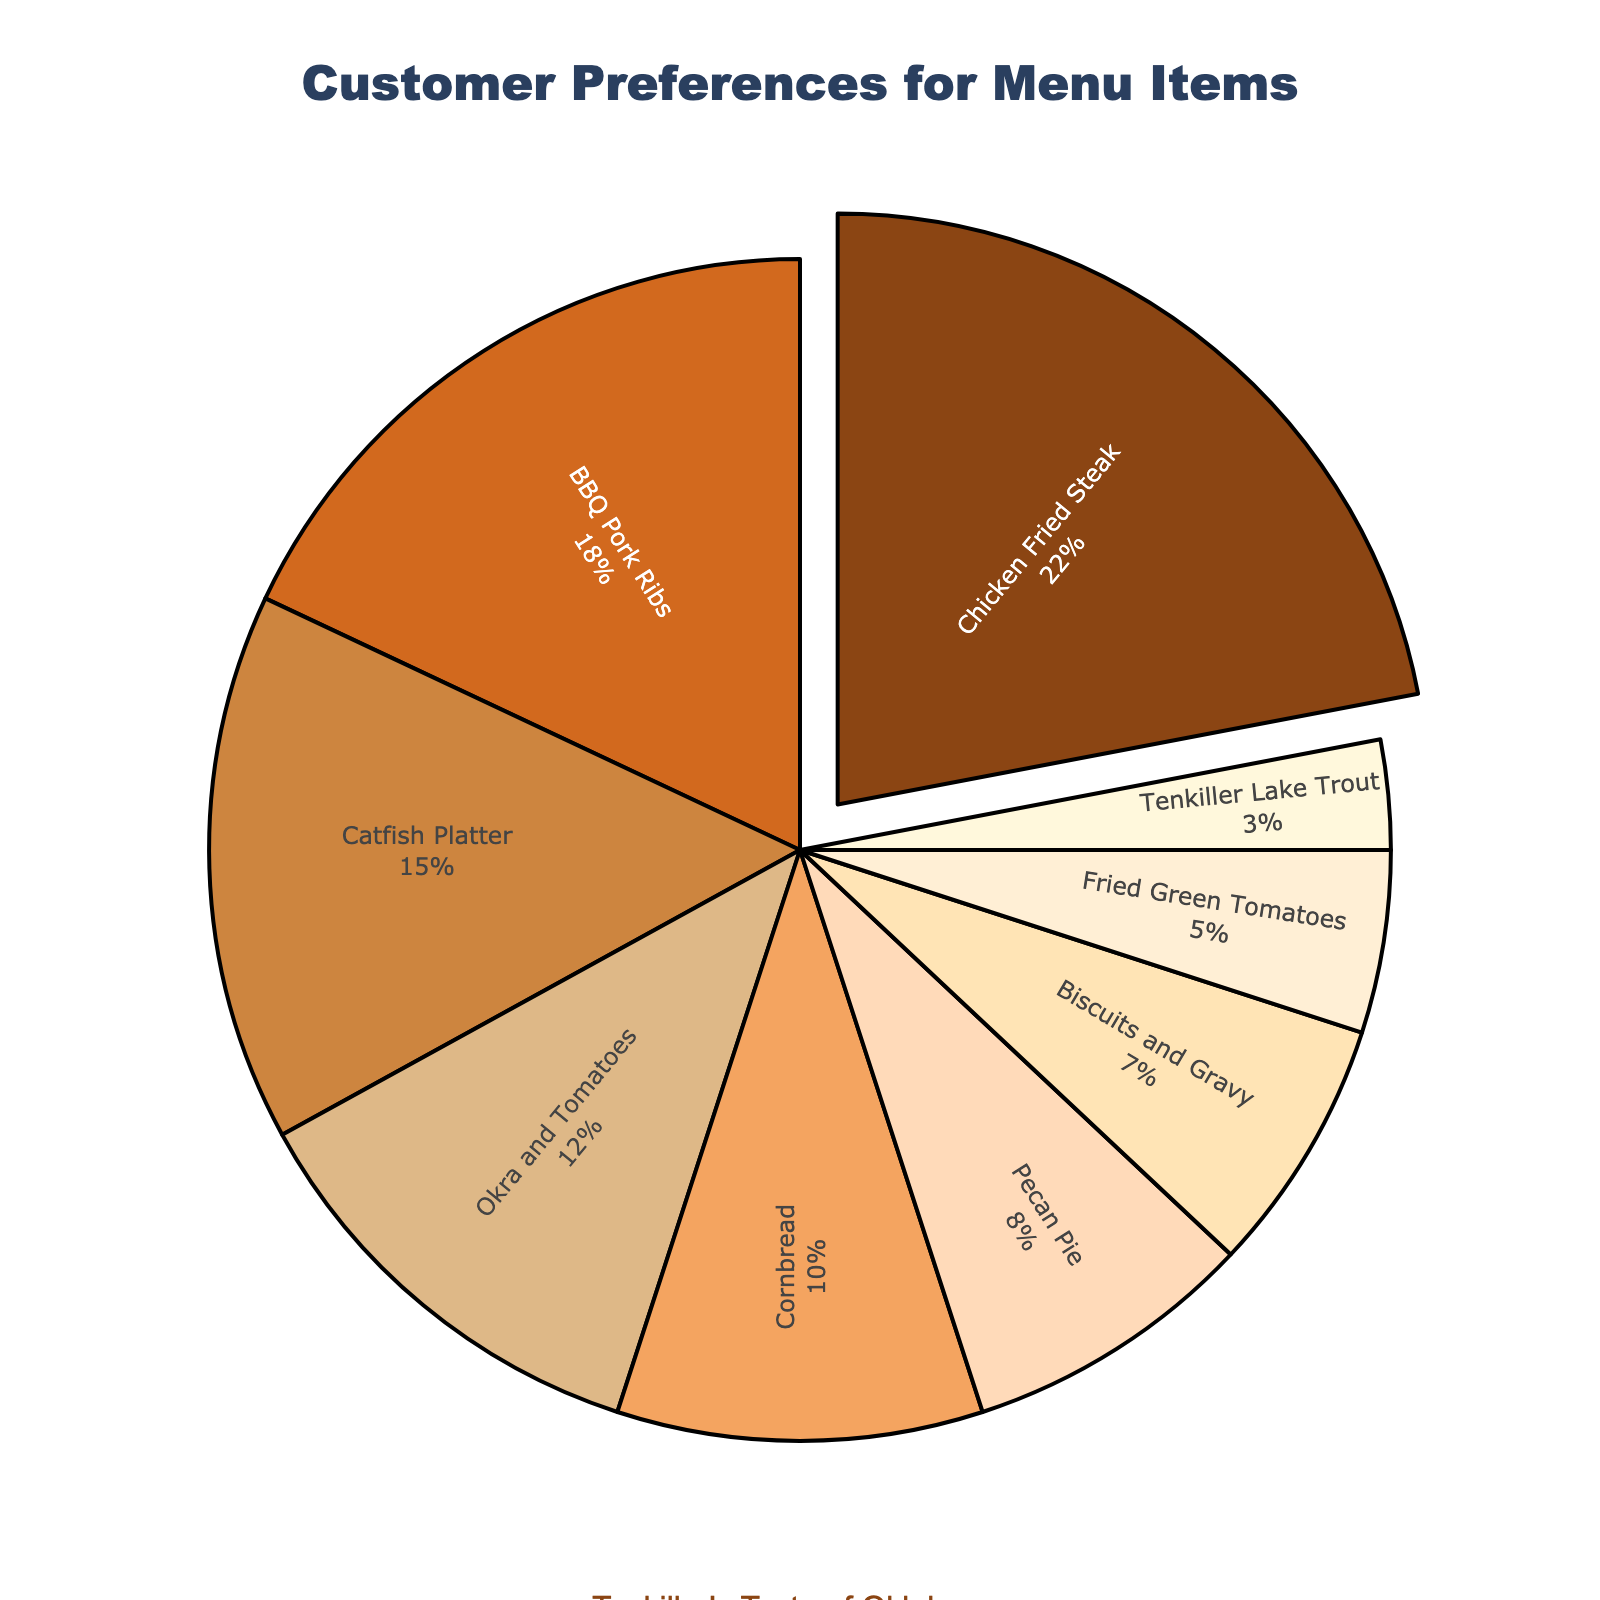How many total percentage points do the "Fried Green Tomatoes" and "Tenkiller Lake Trout" dishes account for? Add the percentage for "Fried Green Tomatoes" (5%) and "Tenkiller Lake Trout" (3%) to get the total percentage they account for.
Answer: 8% Which dish type is the most preferred by customers? The dish type with the highest percentage (largest section of the pie chart) represents the most preferred dish type. "Chicken Fried Steak" accounts for the highest percentage (22%).
Answer: Chicken Fried Steak How does the popularity of "Catfish Platter" compare to "Okra and Tomatoes"? Compare the percentages of the two dish types. "Catfish Platter" has 15% while "Okra and Tomatoes" have 12%. Thus, "Catfish Platter" is more popular by 3 percentage points.
Answer: Catfish Platter is more popular by 3 percentage points What percentage of customers prefer "Biscuits and Gravy"? Locate the section of the pie chart labeled "Biscuits and Gravy" and note its percentage, which is 7%.
Answer: 7% If you combine the percentages of "BBQ Pork Ribs" and "Cornbread", how much is their combined preference among customers? Add the percentages of "BBQ Pork Ribs" (18%) and "Cornbread" (10%) to get their combined preference.
Answer: 28% Which dish type has the smallest slice in the pie chart? The dish type with the smallest percentage (smallest slice of the pie chart) represents the least preferred dish type. "Tenkiller Lake Trout" has the smallest slice with 3%.
Answer: Tenkiller Lake Trout How many more percentage points does "Pecan Pie" have compared to "Fried Green Tomatoes"? Subtract the percentage of "Fried Green Tomatoes" (5%) from the percentage of "Pecan Pie" (8%) to find the difference.
Answer: 3 percentage points What is the combined preference percentage for the bottom three least preferred dishes? Identify the three least preferred dishes from the pie chart: "Biscuits and Gravy" (7%), "Fried Green Tomatoes" (5%), and "Tenkiller Lake Trout" (3%). Add their percentages together.
Answer: 15% Which dish has a preference percentage closest to 10%? Look for the dish type with a percentage closest to 10%. "Cornbread" exactly matches this percentage.
Answer: Cornbread 